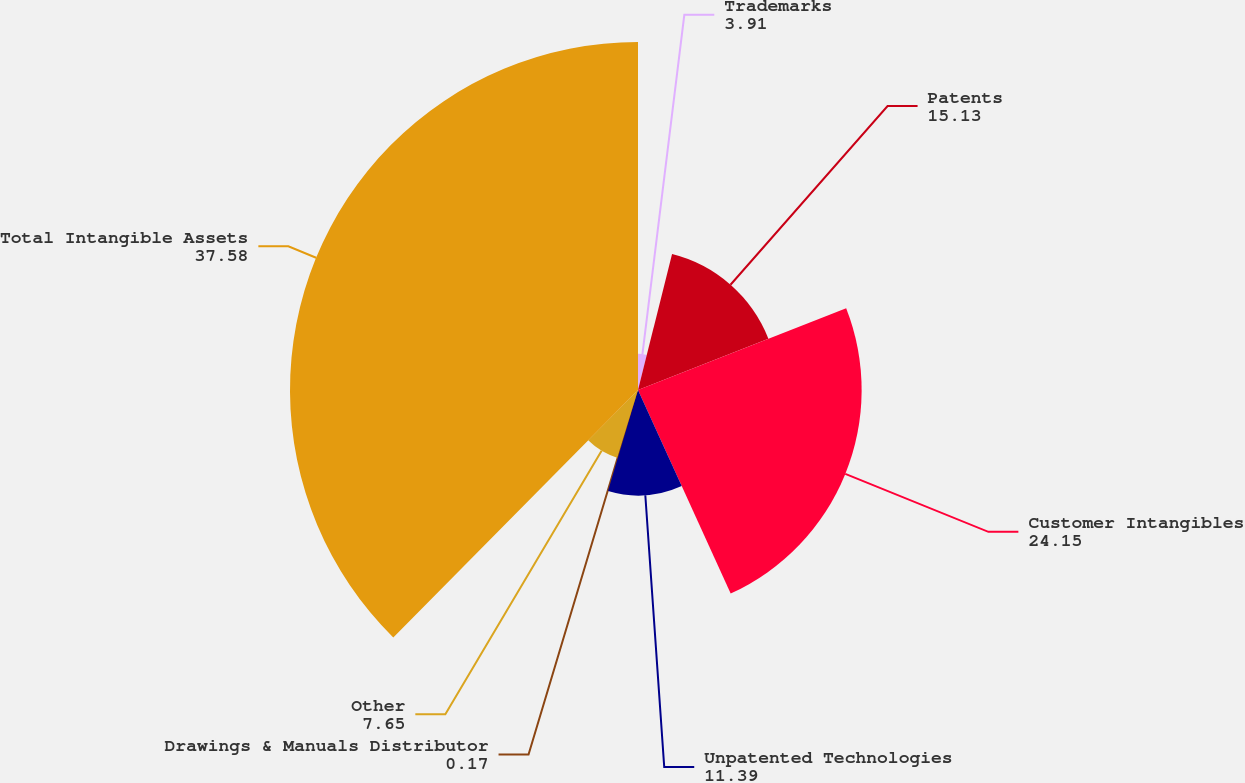Convert chart to OTSL. <chart><loc_0><loc_0><loc_500><loc_500><pie_chart><fcel>Trademarks<fcel>Patents<fcel>Customer Intangibles<fcel>Unpatented Technologies<fcel>Drawings & Manuals Distributor<fcel>Other<fcel>Total Intangible Assets<nl><fcel>3.91%<fcel>15.13%<fcel>24.15%<fcel>11.39%<fcel>0.17%<fcel>7.65%<fcel>37.58%<nl></chart> 